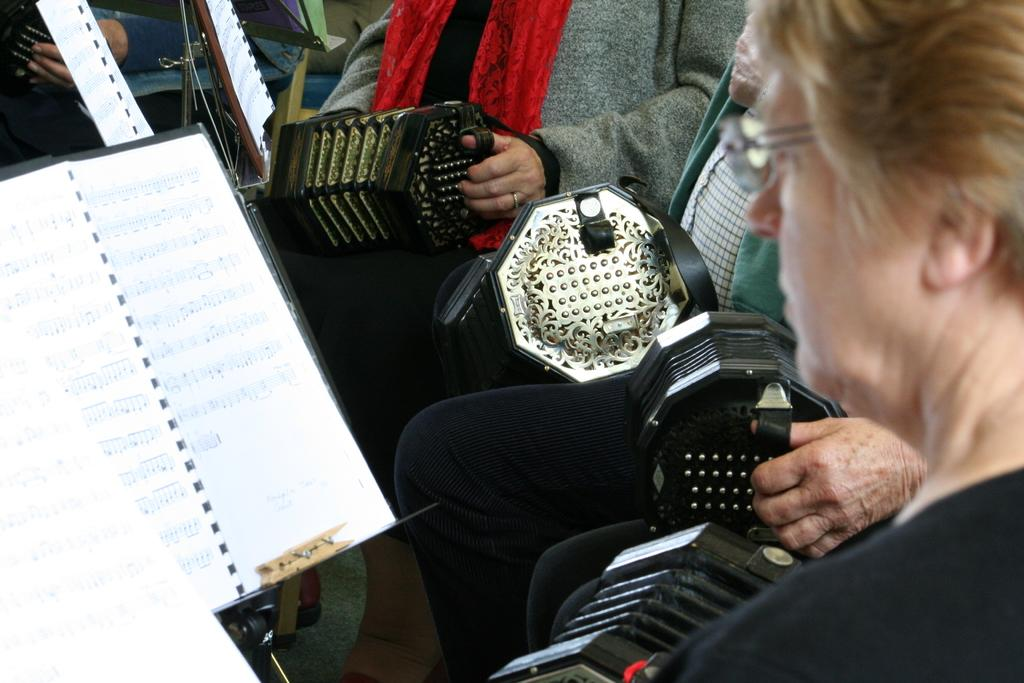What are the persons in the image doing? The persons in the image are sitting on chairs and holding musical instruments. What else can be seen in the image besides the persons and chairs? There is a stand in the image, and a paper is attached to the stand. What language is the lead singer using to communicate with the audience in the image? There is no lead singer or audience present in the image, and therefore no language can be identified. 